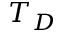<formula> <loc_0><loc_0><loc_500><loc_500>T _ { D }</formula> 